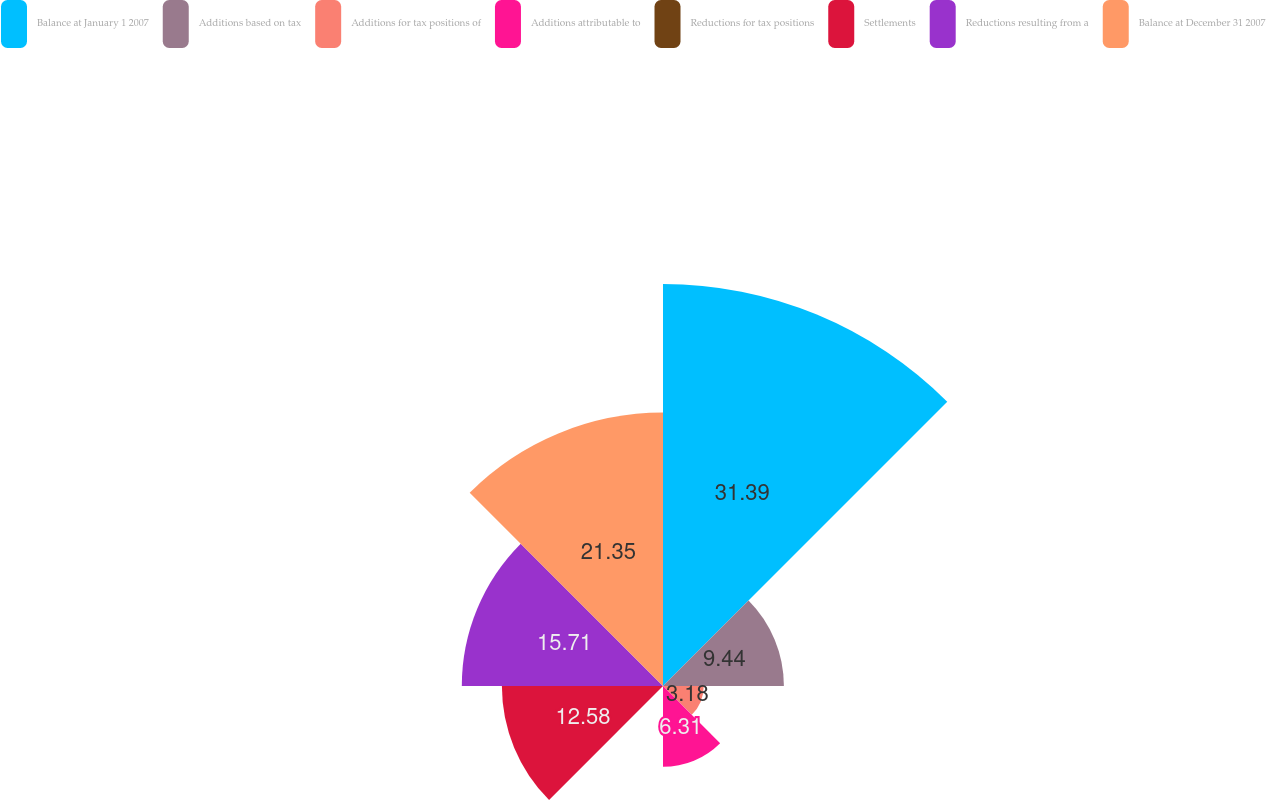<chart> <loc_0><loc_0><loc_500><loc_500><pie_chart><fcel>Balance at January 1 2007<fcel>Additions based on tax<fcel>Additions for tax positions of<fcel>Additions attributable to<fcel>Reductions for tax positions<fcel>Settlements<fcel>Reductions resulting from a<fcel>Balance at December 31 2007<nl><fcel>31.39%<fcel>9.44%<fcel>3.18%<fcel>6.31%<fcel>0.04%<fcel>12.58%<fcel>15.71%<fcel>21.35%<nl></chart> 